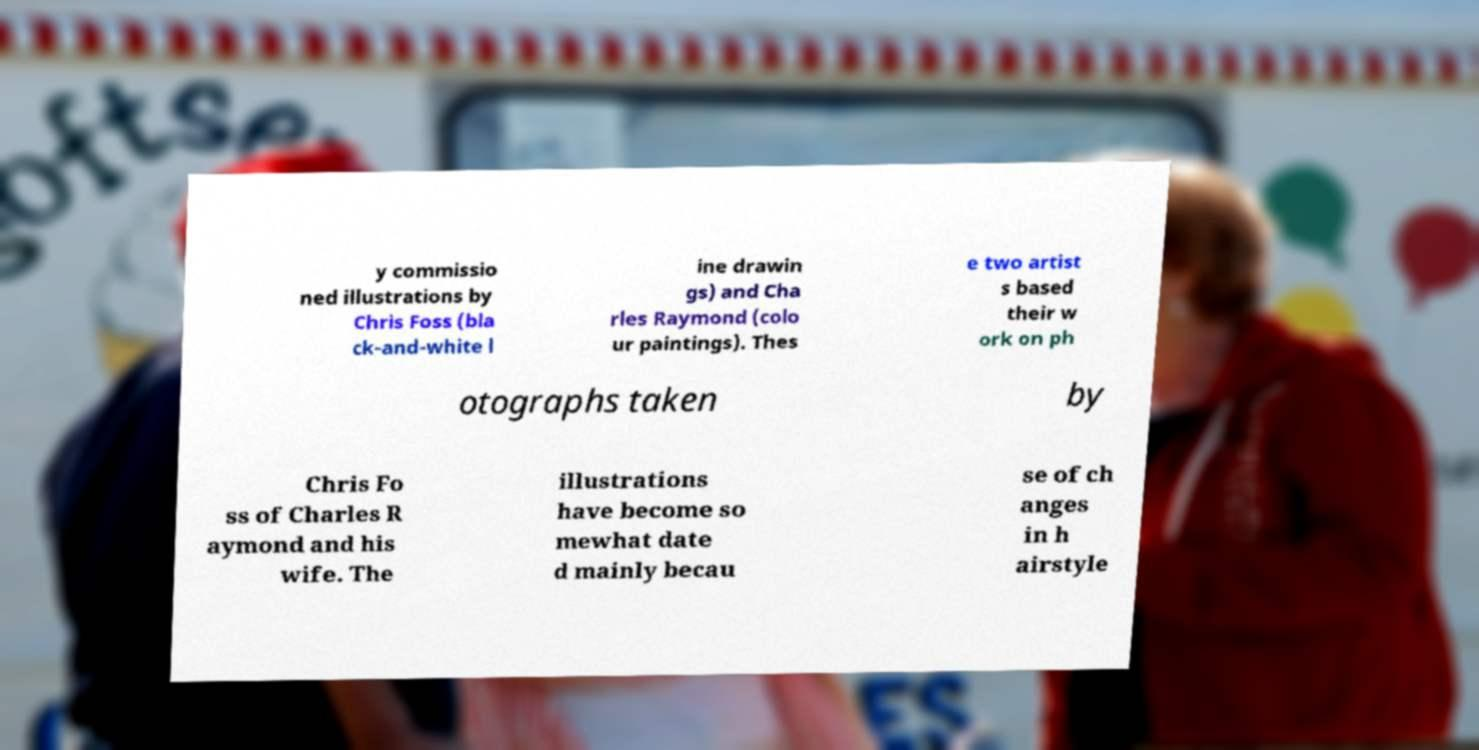Could you extract and type out the text from this image? y commissio ned illustrations by Chris Foss (bla ck-and-white l ine drawin gs) and Cha rles Raymond (colo ur paintings). Thes e two artist s based their w ork on ph otographs taken by Chris Fo ss of Charles R aymond and his wife. The illustrations have become so mewhat date d mainly becau se of ch anges in h airstyle 